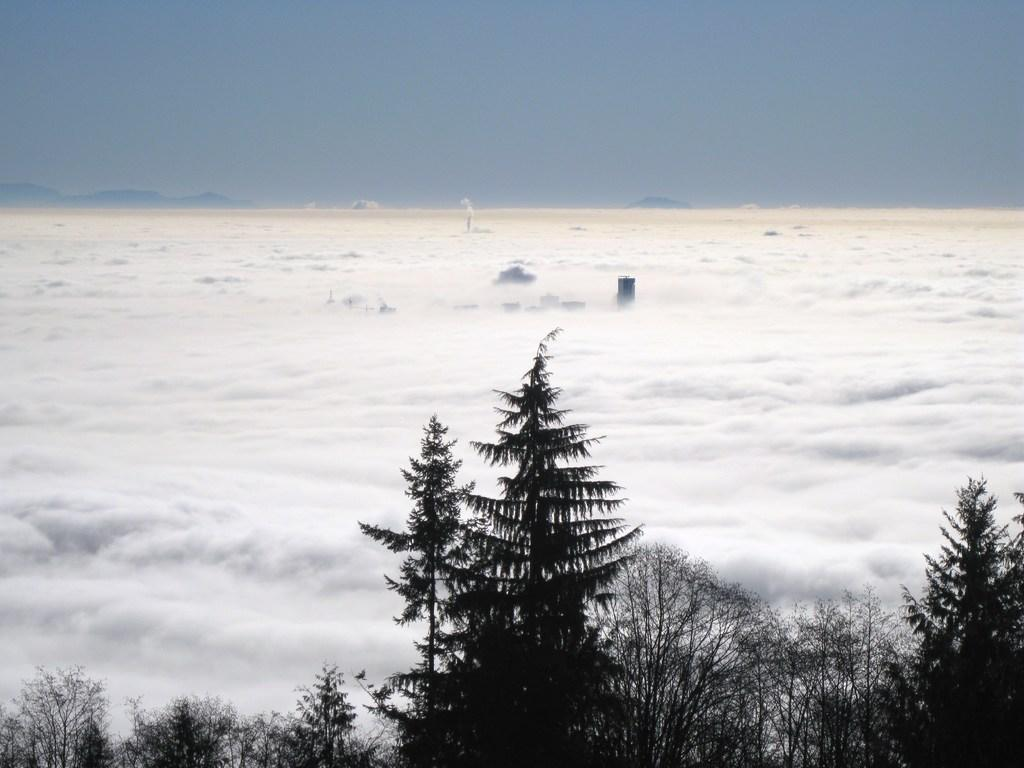What type of natural environment is depicted in the image? There are many trees in the image, suggesting a forest or wooded area. What atmospheric condition is present in the image? There is fog visible in the image. What can be seen in the background of the image? The sky is visible in the background of the image. How deep is the hole in the image? There is no hole present in the image; it features many trees and fog. What type of hand can be seen interacting with the trees in the image? There are no hands or people visible in the image; it only shows trees and fog. 